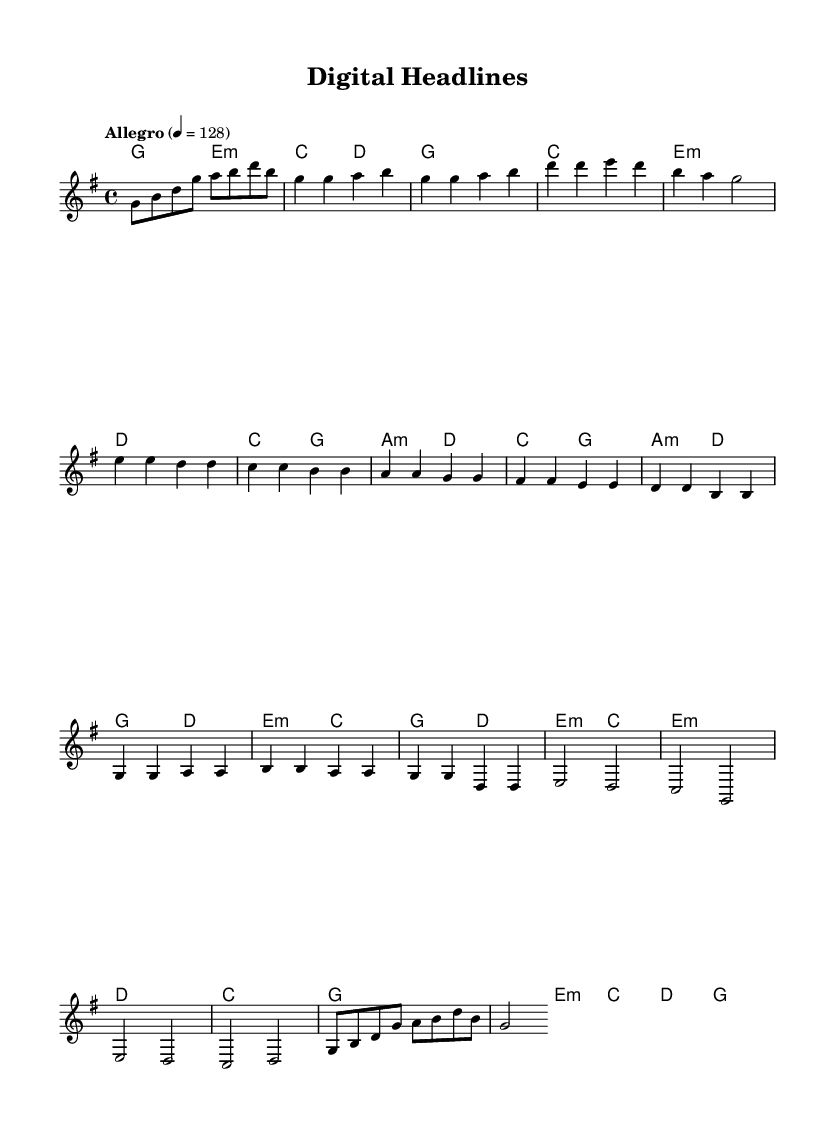What is the key signature of this music? The key signature is G major, which has one sharp (F#) indicated at the beginning of the staff.
Answer: G major What is the time signature of the piece? The time signature is 4/4, as shown at the beginning of the score, indicating four beats in each measure and a quarter note receives one beat.
Answer: 4/4 What is the tempo marking for this piece? The tempo marking is "Allegro," which suggests the piece should be played at a fast tempo, specifically 128 beats per minute as indicated in the score.
Answer: Allegro How many measures are there in the chorus section? The chorus consists of four measures as indicated by the layout of the notes between the repeated sections within the score.
Answer: Four What chord is played in the bridge of the piece? The bridge section begins with an E minor chord, which is reflected in the chord names and harmonization provided in the score.
Answer: E minor Identify the last note in the outro. The last note in the outro section is a G, which concludes the piece based on the melody line shown in the final measure.
Answer: G 